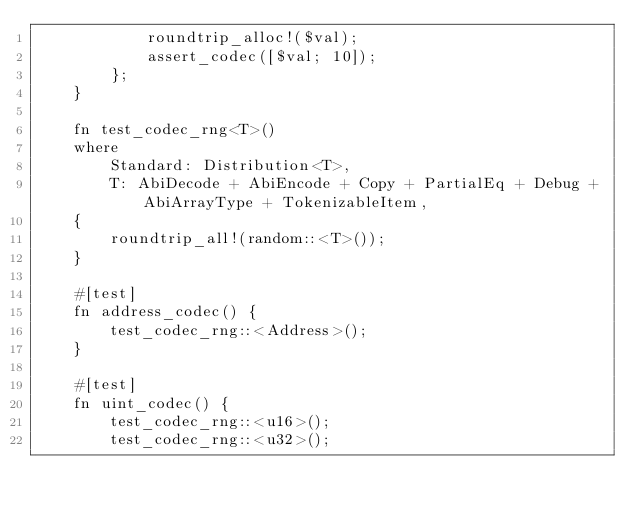Convert code to text. <code><loc_0><loc_0><loc_500><loc_500><_Rust_>            roundtrip_alloc!($val);
            assert_codec([$val; 10]);
        };
    }

    fn test_codec_rng<T>()
    where
        Standard: Distribution<T>,
        T: AbiDecode + AbiEncode + Copy + PartialEq + Debug + AbiArrayType + TokenizableItem,
    {
        roundtrip_all!(random::<T>());
    }

    #[test]
    fn address_codec() {
        test_codec_rng::<Address>();
    }

    #[test]
    fn uint_codec() {
        test_codec_rng::<u16>();
        test_codec_rng::<u32>();</code> 